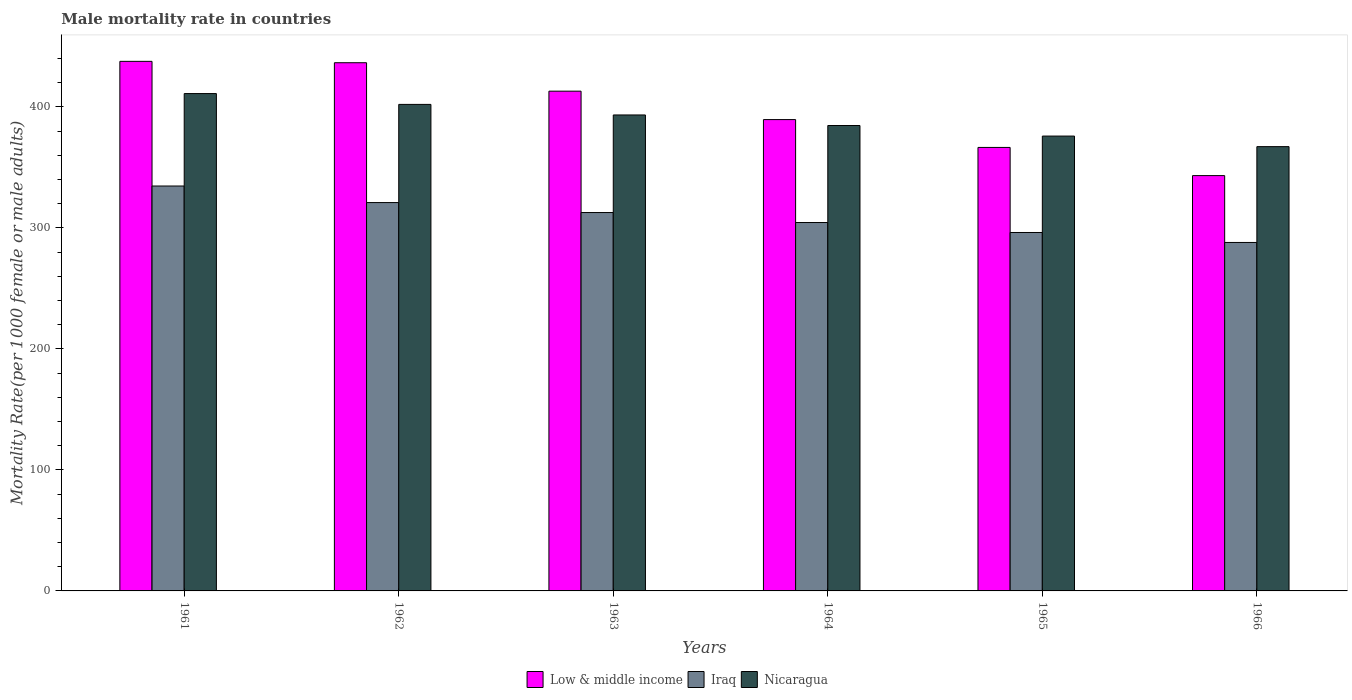Are the number of bars per tick equal to the number of legend labels?
Keep it short and to the point. Yes. Are the number of bars on each tick of the X-axis equal?
Keep it short and to the point. Yes. What is the label of the 6th group of bars from the left?
Give a very brief answer. 1966. What is the male mortality rate in Nicaragua in 1963?
Keep it short and to the point. 393.4. Across all years, what is the maximum male mortality rate in Low & middle income?
Your response must be concise. 437.7. Across all years, what is the minimum male mortality rate in Nicaragua?
Offer a terse response. 367.22. In which year was the male mortality rate in Low & middle income minimum?
Offer a terse response. 1966. What is the total male mortality rate in Iraq in the graph?
Your answer should be very brief. 1857.15. What is the difference between the male mortality rate in Iraq in 1963 and that in 1966?
Ensure brevity in your answer.  24.73. What is the difference between the male mortality rate in Nicaragua in 1966 and the male mortality rate in Low & middle income in 1963?
Give a very brief answer. -45.85. What is the average male mortality rate in Nicaragua per year?
Provide a short and direct response. 389.07. In the year 1961, what is the difference between the male mortality rate in Low & middle income and male mortality rate in Nicaragua?
Your response must be concise. 26.63. In how many years, is the male mortality rate in Iraq greater than 420?
Ensure brevity in your answer.  0. What is the ratio of the male mortality rate in Nicaragua in 1961 to that in 1963?
Keep it short and to the point. 1.04. Is the male mortality rate in Nicaragua in 1964 less than that in 1965?
Your answer should be very brief. No. Is the difference between the male mortality rate in Low & middle income in 1963 and 1966 greater than the difference between the male mortality rate in Nicaragua in 1963 and 1966?
Keep it short and to the point. Yes. What is the difference between the highest and the second highest male mortality rate in Nicaragua?
Provide a short and direct response. 8.94. What is the difference between the highest and the lowest male mortality rate in Nicaragua?
Your response must be concise. 43.86. In how many years, is the male mortality rate in Low & middle income greater than the average male mortality rate in Low & middle income taken over all years?
Ensure brevity in your answer.  3. What does the 3rd bar from the left in 1962 represents?
Provide a short and direct response. Nicaragua. Is it the case that in every year, the sum of the male mortality rate in Nicaragua and male mortality rate in Iraq is greater than the male mortality rate in Low & middle income?
Offer a terse response. Yes. How many bars are there?
Keep it short and to the point. 18. How many years are there in the graph?
Keep it short and to the point. 6. What is the difference between two consecutive major ticks on the Y-axis?
Keep it short and to the point. 100. Are the values on the major ticks of Y-axis written in scientific E-notation?
Your answer should be very brief. No. Does the graph contain grids?
Your answer should be compact. No. How many legend labels are there?
Provide a succinct answer. 3. How are the legend labels stacked?
Provide a short and direct response. Horizontal. What is the title of the graph?
Ensure brevity in your answer.  Male mortality rate in countries. What is the label or title of the Y-axis?
Your response must be concise. Mortality Rate(per 1000 female or male adults). What is the Mortality Rate(per 1000 female or male adults) in Low & middle income in 1961?
Offer a terse response. 437.7. What is the Mortality Rate(per 1000 female or male adults) in Iraq in 1961?
Provide a succinct answer. 334.67. What is the Mortality Rate(per 1000 female or male adults) of Nicaragua in 1961?
Your answer should be very brief. 411.07. What is the Mortality Rate(per 1000 female or male adults) of Low & middle income in 1962?
Provide a succinct answer. 436.57. What is the Mortality Rate(per 1000 female or male adults) of Iraq in 1962?
Provide a short and direct response. 320.98. What is the Mortality Rate(per 1000 female or male adults) in Nicaragua in 1962?
Offer a very short reply. 402.13. What is the Mortality Rate(per 1000 female or male adults) of Low & middle income in 1963?
Provide a short and direct response. 413.06. What is the Mortality Rate(per 1000 female or male adults) in Iraq in 1963?
Keep it short and to the point. 312.74. What is the Mortality Rate(per 1000 female or male adults) of Nicaragua in 1963?
Your answer should be very brief. 393.4. What is the Mortality Rate(per 1000 female or male adults) of Low & middle income in 1964?
Give a very brief answer. 389.57. What is the Mortality Rate(per 1000 female or male adults) in Iraq in 1964?
Give a very brief answer. 304.5. What is the Mortality Rate(per 1000 female or male adults) of Nicaragua in 1964?
Make the answer very short. 384.67. What is the Mortality Rate(per 1000 female or male adults) of Low & middle income in 1965?
Your response must be concise. 366.55. What is the Mortality Rate(per 1000 female or male adults) of Iraq in 1965?
Keep it short and to the point. 296.25. What is the Mortality Rate(per 1000 female or male adults) in Nicaragua in 1965?
Offer a terse response. 375.94. What is the Mortality Rate(per 1000 female or male adults) in Low & middle income in 1966?
Your response must be concise. 343.27. What is the Mortality Rate(per 1000 female or male adults) of Iraq in 1966?
Your answer should be very brief. 288.01. What is the Mortality Rate(per 1000 female or male adults) in Nicaragua in 1966?
Offer a terse response. 367.22. Across all years, what is the maximum Mortality Rate(per 1000 female or male adults) of Low & middle income?
Make the answer very short. 437.7. Across all years, what is the maximum Mortality Rate(per 1000 female or male adults) of Iraq?
Make the answer very short. 334.67. Across all years, what is the maximum Mortality Rate(per 1000 female or male adults) in Nicaragua?
Ensure brevity in your answer.  411.07. Across all years, what is the minimum Mortality Rate(per 1000 female or male adults) in Low & middle income?
Your response must be concise. 343.27. Across all years, what is the minimum Mortality Rate(per 1000 female or male adults) in Iraq?
Provide a succinct answer. 288.01. Across all years, what is the minimum Mortality Rate(per 1000 female or male adults) of Nicaragua?
Offer a very short reply. 367.22. What is the total Mortality Rate(per 1000 female or male adults) in Low & middle income in the graph?
Provide a short and direct response. 2386.73. What is the total Mortality Rate(per 1000 female or male adults) in Iraq in the graph?
Your answer should be very brief. 1857.15. What is the total Mortality Rate(per 1000 female or male adults) in Nicaragua in the graph?
Provide a short and direct response. 2334.43. What is the difference between the Mortality Rate(per 1000 female or male adults) in Low & middle income in 1961 and that in 1962?
Your answer should be compact. 1.13. What is the difference between the Mortality Rate(per 1000 female or male adults) in Iraq in 1961 and that in 1962?
Give a very brief answer. 13.69. What is the difference between the Mortality Rate(per 1000 female or male adults) of Nicaragua in 1961 and that in 1962?
Your answer should be very brief. 8.94. What is the difference between the Mortality Rate(per 1000 female or male adults) in Low & middle income in 1961 and that in 1963?
Your answer should be very brief. 24.64. What is the difference between the Mortality Rate(per 1000 female or male adults) of Iraq in 1961 and that in 1963?
Your answer should be very brief. 21.93. What is the difference between the Mortality Rate(per 1000 female or male adults) in Nicaragua in 1961 and that in 1963?
Your response must be concise. 17.67. What is the difference between the Mortality Rate(per 1000 female or male adults) in Low & middle income in 1961 and that in 1964?
Ensure brevity in your answer.  48.13. What is the difference between the Mortality Rate(per 1000 female or male adults) of Iraq in 1961 and that in 1964?
Your answer should be compact. 30.17. What is the difference between the Mortality Rate(per 1000 female or male adults) in Nicaragua in 1961 and that in 1964?
Offer a terse response. 26.4. What is the difference between the Mortality Rate(per 1000 female or male adults) of Low & middle income in 1961 and that in 1965?
Your answer should be very brief. 71.15. What is the difference between the Mortality Rate(per 1000 female or male adults) of Iraq in 1961 and that in 1965?
Keep it short and to the point. 38.42. What is the difference between the Mortality Rate(per 1000 female or male adults) of Nicaragua in 1961 and that in 1965?
Keep it short and to the point. 35.13. What is the difference between the Mortality Rate(per 1000 female or male adults) in Low & middle income in 1961 and that in 1966?
Keep it short and to the point. 94.43. What is the difference between the Mortality Rate(per 1000 female or male adults) of Iraq in 1961 and that in 1966?
Give a very brief answer. 46.66. What is the difference between the Mortality Rate(per 1000 female or male adults) of Nicaragua in 1961 and that in 1966?
Offer a terse response. 43.86. What is the difference between the Mortality Rate(per 1000 female or male adults) in Low & middle income in 1962 and that in 1963?
Keep it short and to the point. 23.51. What is the difference between the Mortality Rate(per 1000 female or male adults) in Iraq in 1962 and that in 1963?
Give a very brief answer. 8.24. What is the difference between the Mortality Rate(per 1000 female or male adults) of Nicaragua in 1962 and that in 1963?
Your answer should be very brief. 8.73. What is the difference between the Mortality Rate(per 1000 female or male adults) of Low & middle income in 1962 and that in 1964?
Provide a short and direct response. 47. What is the difference between the Mortality Rate(per 1000 female or male adults) in Iraq in 1962 and that in 1964?
Your answer should be very brief. 16.48. What is the difference between the Mortality Rate(per 1000 female or male adults) of Nicaragua in 1962 and that in 1964?
Give a very brief answer. 17.46. What is the difference between the Mortality Rate(per 1000 female or male adults) in Low & middle income in 1962 and that in 1965?
Offer a very short reply. 70.02. What is the difference between the Mortality Rate(per 1000 female or male adults) in Iraq in 1962 and that in 1965?
Provide a short and direct response. 24.73. What is the difference between the Mortality Rate(per 1000 female or male adults) of Nicaragua in 1962 and that in 1965?
Offer a very short reply. 26.18. What is the difference between the Mortality Rate(per 1000 female or male adults) of Low & middle income in 1962 and that in 1966?
Your response must be concise. 93.29. What is the difference between the Mortality Rate(per 1000 female or male adults) of Iraq in 1962 and that in 1966?
Ensure brevity in your answer.  32.97. What is the difference between the Mortality Rate(per 1000 female or male adults) of Nicaragua in 1962 and that in 1966?
Offer a terse response. 34.91. What is the difference between the Mortality Rate(per 1000 female or male adults) of Low & middle income in 1963 and that in 1964?
Provide a short and direct response. 23.5. What is the difference between the Mortality Rate(per 1000 female or male adults) of Iraq in 1963 and that in 1964?
Give a very brief answer. 8.24. What is the difference between the Mortality Rate(per 1000 female or male adults) in Nicaragua in 1963 and that in 1964?
Offer a very short reply. 8.73. What is the difference between the Mortality Rate(per 1000 female or male adults) in Low & middle income in 1963 and that in 1965?
Your answer should be compact. 46.51. What is the difference between the Mortality Rate(per 1000 female or male adults) in Iraq in 1963 and that in 1965?
Give a very brief answer. 16.48. What is the difference between the Mortality Rate(per 1000 female or male adults) in Nicaragua in 1963 and that in 1965?
Your answer should be very brief. 17.46. What is the difference between the Mortality Rate(per 1000 female or male adults) in Low & middle income in 1963 and that in 1966?
Keep it short and to the point. 69.79. What is the difference between the Mortality Rate(per 1000 female or male adults) of Iraq in 1963 and that in 1966?
Make the answer very short. 24.73. What is the difference between the Mortality Rate(per 1000 female or male adults) of Nicaragua in 1963 and that in 1966?
Your answer should be compact. 26.18. What is the difference between the Mortality Rate(per 1000 female or male adults) in Low & middle income in 1964 and that in 1965?
Make the answer very short. 23.02. What is the difference between the Mortality Rate(per 1000 female or male adults) of Iraq in 1964 and that in 1965?
Your answer should be very brief. 8.24. What is the difference between the Mortality Rate(per 1000 female or male adults) of Nicaragua in 1964 and that in 1965?
Provide a short and direct response. 8.73. What is the difference between the Mortality Rate(per 1000 female or male adults) of Low & middle income in 1964 and that in 1966?
Your answer should be very brief. 46.29. What is the difference between the Mortality Rate(per 1000 female or male adults) of Iraq in 1964 and that in 1966?
Offer a terse response. 16.48. What is the difference between the Mortality Rate(per 1000 female or male adults) of Nicaragua in 1964 and that in 1966?
Offer a terse response. 17.46. What is the difference between the Mortality Rate(per 1000 female or male adults) in Low & middle income in 1965 and that in 1966?
Your answer should be very brief. 23.28. What is the difference between the Mortality Rate(per 1000 female or male adults) of Iraq in 1965 and that in 1966?
Ensure brevity in your answer.  8.24. What is the difference between the Mortality Rate(per 1000 female or male adults) of Nicaragua in 1965 and that in 1966?
Offer a very short reply. 8.73. What is the difference between the Mortality Rate(per 1000 female or male adults) in Low & middle income in 1961 and the Mortality Rate(per 1000 female or male adults) in Iraq in 1962?
Make the answer very short. 116.72. What is the difference between the Mortality Rate(per 1000 female or male adults) of Low & middle income in 1961 and the Mortality Rate(per 1000 female or male adults) of Nicaragua in 1962?
Your answer should be very brief. 35.57. What is the difference between the Mortality Rate(per 1000 female or male adults) in Iraq in 1961 and the Mortality Rate(per 1000 female or male adults) in Nicaragua in 1962?
Provide a succinct answer. -67.46. What is the difference between the Mortality Rate(per 1000 female or male adults) in Low & middle income in 1961 and the Mortality Rate(per 1000 female or male adults) in Iraq in 1963?
Make the answer very short. 124.97. What is the difference between the Mortality Rate(per 1000 female or male adults) in Low & middle income in 1961 and the Mortality Rate(per 1000 female or male adults) in Nicaragua in 1963?
Give a very brief answer. 44.3. What is the difference between the Mortality Rate(per 1000 female or male adults) in Iraq in 1961 and the Mortality Rate(per 1000 female or male adults) in Nicaragua in 1963?
Offer a very short reply. -58.73. What is the difference between the Mortality Rate(per 1000 female or male adults) of Low & middle income in 1961 and the Mortality Rate(per 1000 female or male adults) of Iraq in 1964?
Ensure brevity in your answer.  133.21. What is the difference between the Mortality Rate(per 1000 female or male adults) of Low & middle income in 1961 and the Mortality Rate(per 1000 female or male adults) of Nicaragua in 1964?
Keep it short and to the point. 53.03. What is the difference between the Mortality Rate(per 1000 female or male adults) of Iraq in 1961 and the Mortality Rate(per 1000 female or male adults) of Nicaragua in 1964?
Keep it short and to the point. -50. What is the difference between the Mortality Rate(per 1000 female or male adults) in Low & middle income in 1961 and the Mortality Rate(per 1000 female or male adults) in Iraq in 1965?
Your answer should be very brief. 141.45. What is the difference between the Mortality Rate(per 1000 female or male adults) of Low & middle income in 1961 and the Mortality Rate(per 1000 female or male adults) of Nicaragua in 1965?
Offer a very short reply. 61.76. What is the difference between the Mortality Rate(per 1000 female or male adults) of Iraq in 1961 and the Mortality Rate(per 1000 female or male adults) of Nicaragua in 1965?
Provide a short and direct response. -41.27. What is the difference between the Mortality Rate(per 1000 female or male adults) in Low & middle income in 1961 and the Mortality Rate(per 1000 female or male adults) in Iraq in 1966?
Your answer should be compact. 149.69. What is the difference between the Mortality Rate(per 1000 female or male adults) in Low & middle income in 1961 and the Mortality Rate(per 1000 female or male adults) in Nicaragua in 1966?
Ensure brevity in your answer.  70.49. What is the difference between the Mortality Rate(per 1000 female or male adults) in Iraq in 1961 and the Mortality Rate(per 1000 female or male adults) in Nicaragua in 1966?
Keep it short and to the point. -32.55. What is the difference between the Mortality Rate(per 1000 female or male adults) in Low & middle income in 1962 and the Mortality Rate(per 1000 female or male adults) in Iraq in 1963?
Make the answer very short. 123.83. What is the difference between the Mortality Rate(per 1000 female or male adults) of Low & middle income in 1962 and the Mortality Rate(per 1000 female or male adults) of Nicaragua in 1963?
Your answer should be very brief. 43.17. What is the difference between the Mortality Rate(per 1000 female or male adults) in Iraq in 1962 and the Mortality Rate(per 1000 female or male adults) in Nicaragua in 1963?
Ensure brevity in your answer.  -72.42. What is the difference between the Mortality Rate(per 1000 female or male adults) in Low & middle income in 1962 and the Mortality Rate(per 1000 female or male adults) in Iraq in 1964?
Provide a succinct answer. 132.07. What is the difference between the Mortality Rate(per 1000 female or male adults) in Low & middle income in 1962 and the Mortality Rate(per 1000 female or male adults) in Nicaragua in 1964?
Your response must be concise. 51.9. What is the difference between the Mortality Rate(per 1000 female or male adults) of Iraq in 1962 and the Mortality Rate(per 1000 female or male adults) of Nicaragua in 1964?
Provide a short and direct response. -63.69. What is the difference between the Mortality Rate(per 1000 female or male adults) of Low & middle income in 1962 and the Mortality Rate(per 1000 female or male adults) of Iraq in 1965?
Offer a very short reply. 140.32. What is the difference between the Mortality Rate(per 1000 female or male adults) in Low & middle income in 1962 and the Mortality Rate(per 1000 female or male adults) in Nicaragua in 1965?
Provide a short and direct response. 60.63. What is the difference between the Mortality Rate(per 1000 female or male adults) of Iraq in 1962 and the Mortality Rate(per 1000 female or male adults) of Nicaragua in 1965?
Your answer should be compact. -54.96. What is the difference between the Mortality Rate(per 1000 female or male adults) of Low & middle income in 1962 and the Mortality Rate(per 1000 female or male adults) of Iraq in 1966?
Ensure brevity in your answer.  148.56. What is the difference between the Mortality Rate(per 1000 female or male adults) in Low & middle income in 1962 and the Mortality Rate(per 1000 female or male adults) in Nicaragua in 1966?
Your answer should be very brief. 69.35. What is the difference between the Mortality Rate(per 1000 female or male adults) of Iraq in 1962 and the Mortality Rate(per 1000 female or male adults) of Nicaragua in 1966?
Your answer should be very brief. -46.24. What is the difference between the Mortality Rate(per 1000 female or male adults) of Low & middle income in 1963 and the Mortality Rate(per 1000 female or male adults) of Iraq in 1964?
Offer a very short reply. 108.57. What is the difference between the Mortality Rate(per 1000 female or male adults) in Low & middle income in 1963 and the Mortality Rate(per 1000 female or male adults) in Nicaragua in 1964?
Provide a short and direct response. 28.39. What is the difference between the Mortality Rate(per 1000 female or male adults) of Iraq in 1963 and the Mortality Rate(per 1000 female or male adults) of Nicaragua in 1964?
Give a very brief answer. -71.93. What is the difference between the Mortality Rate(per 1000 female or male adults) of Low & middle income in 1963 and the Mortality Rate(per 1000 female or male adults) of Iraq in 1965?
Your response must be concise. 116.81. What is the difference between the Mortality Rate(per 1000 female or male adults) in Low & middle income in 1963 and the Mortality Rate(per 1000 female or male adults) in Nicaragua in 1965?
Offer a terse response. 37.12. What is the difference between the Mortality Rate(per 1000 female or male adults) of Iraq in 1963 and the Mortality Rate(per 1000 female or male adults) of Nicaragua in 1965?
Offer a terse response. -63.21. What is the difference between the Mortality Rate(per 1000 female or male adults) of Low & middle income in 1963 and the Mortality Rate(per 1000 female or male adults) of Iraq in 1966?
Offer a very short reply. 125.05. What is the difference between the Mortality Rate(per 1000 female or male adults) of Low & middle income in 1963 and the Mortality Rate(per 1000 female or male adults) of Nicaragua in 1966?
Provide a short and direct response. 45.85. What is the difference between the Mortality Rate(per 1000 female or male adults) of Iraq in 1963 and the Mortality Rate(per 1000 female or male adults) of Nicaragua in 1966?
Provide a short and direct response. -54.48. What is the difference between the Mortality Rate(per 1000 female or male adults) in Low & middle income in 1964 and the Mortality Rate(per 1000 female or male adults) in Iraq in 1965?
Offer a very short reply. 93.31. What is the difference between the Mortality Rate(per 1000 female or male adults) in Low & middle income in 1964 and the Mortality Rate(per 1000 female or male adults) in Nicaragua in 1965?
Your response must be concise. 13.62. What is the difference between the Mortality Rate(per 1000 female or male adults) in Iraq in 1964 and the Mortality Rate(per 1000 female or male adults) in Nicaragua in 1965?
Your answer should be very brief. -71.45. What is the difference between the Mortality Rate(per 1000 female or male adults) of Low & middle income in 1964 and the Mortality Rate(per 1000 female or male adults) of Iraq in 1966?
Your response must be concise. 101.56. What is the difference between the Mortality Rate(per 1000 female or male adults) in Low & middle income in 1964 and the Mortality Rate(per 1000 female or male adults) in Nicaragua in 1966?
Give a very brief answer. 22.35. What is the difference between the Mortality Rate(per 1000 female or male adults) of Iraq in 1964 and the Mortality Rate(per 1000 female or male adults) of Nicaragua in 1966?
Keep it short and to the point. -62.72. What is the difference between the Mortality Rate(per 1000 female or male adults) of Low & middle income in 1965 and the Mortality Rate(per 1000 female or male adults) of Iraq in 1966?
Your answer should be very brief. 78.54. What is the difference between the Mortality Rate(per 1000 female or male adults) of Low & middle income in 1965 and the Mortality Rate(per 1000 female or male adults) of Nicaragua in 1966?
Your answer should be compact. -0.66. What is the difference between the Mortality Rate(per 1000 female or male adults) in Iraq in 1965 and the Mortality Rate(per 1000 female or male adults) in Nicaragua in 1966?
Offer a terse response. -70.96. What is the average Mortality Rate(per 1000 female or male adults) of Low & middle income per year?
Make the answer very short. 397.79. What is the average Mortality Rate(per 1000 female or male adults) of Iraq per year?
Provide a short and direct response. 309.52. What is the average Mortality Rate(per 1000 female or male adults) of Nicaragua per year?
Ensure brevity in your answer.  389.07. In the year 1961, what is the difference between the Mortality Rate(per 1000 female or male adults) of Low & middle income and Mortality Rate(per 1000 female or male adults) of Iraq?
Provide a succinct answer. 103.03. In the year 1961, what is the difference between the Mortality Rate(per 1000 female or male adults) of Low & middle income and Mortality Rate(per 1000 female or male adults) of Nicaragua?
Ensure brevity in your answer.  26.63. In the year 1961, what is the difference between the Mortality Rate(per 1000 female or male adults) of Iraq and Mortality Rate(per 1000 female or male adults) of Nicaragua?
Make the answer very short. -76.4. In the year 1962, what is the difference between the Mortality Rate(per 1000 female or male adults) of Low & middle income and Mortality Rate(per 1000 female or male adults) of Iraq?
Provide a succinct answer. 115.59. In the year 1962, what is the difference between the Mortality Rate(per 1000 female or male adults) in Low & middle income and Mortality Rate(per 1000 female or male adults) in Nicaragua?
Give a very brief answer. 34.44. In the year 1962, what is the difference between the Mortality Rate(per 1000 female or male adults) in Iraq and Mortality Rate(per 1000 female or male adults) in Nicaragua?
Provide a short and direct response. -81.15. In the year 1963, what is the difference between the Mortality Rate(per 1000 female or male adults) of Low & middle income and Mortality Rate(per 1000 female or male adults) of Iraq?
Make the answer very short. 100.33. In the year 1963, what is the difference between the Mortality Rate(per 1000 female or male adults) of Low & middle income and Mortality Rate(per 1000 female or male adults) of Nicaragua?
Your response must be concise. 19.66. In the year 1963, what is the difference between the Mortality Rate(per 1000 female or male adults) of Iraq and Mortality Rate(per 1000 female or male adults) of Nicaragua?
Offer a terse response. -80.66. In the year 1964, what is the difference between the Mortality Rate(per 1000 female or male adults) of Low & middle income and Mortality Rate(per 1000 female or male adults) of Iraq?
Offer a very short reply. 85.07. In the year 1964, what is the difference between the Mortality Rate(per 1000 female or male adults) in Low & middle income and Mortality Rate(per 1000 female or male adults) in Nicaragua?
Your answer should be compact. 4.9. In the year 1964, what is the difference between the Mortality Rate(per 1000 female or male adults) of Iraq and Mortality Rate(per 1000 female or male adults) of Nicaragua?
Provide a succinct answer. -80.18. In the year 1965, what is the difference between the Mortality Rate(per 1000 female or male adults) in Low & middle income and Mortality Rate(per 1000 female or male adults) in Iraq?
Offer a very short reply. 70.3. In the year 1965, what is the difference between the Mortality Rate(per 1000 female or male adults) in Low & middle income and Mortality Rate(per 1000 female or male adults) in Nicaragua?
Your answer should be compact. -9.39. In the year 1965, what is the difference between the Mortality Rate(per 1000 female or male adults) of Iraq and Mortality Rate(per 1000 female or male adults) of Nicaragua?
Ensure brevity in your answer.  -79.69. In the year 1966, what is the difference between the Mortality Rate(per 1000 female or male adults) in Low & middle income and Mortality Rate(per 1000 female or male adults) in Iraq?
Offer a very short reply. 55.26. In the year 1966, what is the difference between the Mortality Rate(per 1000 female or male adults) in Low & middle income and Mortality Rate(per 1000 female or male adults) in Nicaragua?
Your response must be concise. -23.94. In the year 1966, what is the difference between the Mortality Rate(per 1000 female or male adults) in Iraq and Mortality Rate(per 1000 female or male adults) in Nicaragua?
Your response must be concise. -79.2. What is the ratio of the Mortality Rate(per 1000 female or male adults) in Iraq in 1961 to that in 1962?
Give a very brief answer. 1.04. What is the ratio of the Mortality Rate(per 1000 female or male adults) of Nicaragua in 1961 to that in 1962?
Keep it short and to the point. 1.02. What is the ratio of the Mortality Rate(per 1000 female or male adults) in Low & middle income in 1961 to that in 1963?
Your answer should be compact. 1.06. What is the ratio of the Mortality Rate(per 1000 female or male adults) of Iraq in 1961 to that in 1963?
Your answer should be compact. 1.07. What is the ratio of the Mortality Rate(per 1000 female or male adults) of Nicaragua in 1961 to that in 1963?
Your answer should be compact. 1.04. What is the ratio of the Mortality Rate(per 1000 female or male adults) of Low & middle income in 1961 to that in 1964?
Make the answer very short. 1.12. What is the ratio of the Mortality Rate(per 1000 female or male adults) in Iraq in 1961 to that in 1964?
Give a very brief answer. 1.1. What is the ratio of the Mortality Rate(per 1000 female or male adults) of Nicaragua in 1961 to that in 1964?
Offer a terse response. 1.07. What is the ratio of the Mortality Rate(per 1000 female or male adults) in Low & middle income in 1961 to that in 1965?
Give a very brief answer. 1.19. What is the ratio of the Mortality Rate(per 1000 female or male adults) in Iraq in 1961 to that in 1965?
Your answer should be very brief. 1.13. What is the ratio of the Mortality Rate(per 1000 female or male adults) of Nicaragua in 1961 to that in 1965?
Your answer should be compact. 1.09. What is the ratio of the Mortality Rate(per 1000 female or male adults) of Low & middle income in 1961 to that in 1966?
Offer a terse response. 1.28. What is the ratio of the Mortality Rate(per 1000 female or male adults) of Iraq in 1961 to that in 1966?
Offer a very short reply. 1.16. What is the ratio of the Mortality Rate(per 1000 female or male adults) of Nicaragua in 1961 to that in 1966?
Provide a succinct answer. 1.12. What is the ratio of the Mortality Rate(per 1000 female or male adults) in Low & middle income in 1962 to that in 1963?
Your answer should be compact. 1.06. What is the ratio of the Mortality Rate(per 1000 female or male adults) of Iraq in 1962 to that in 1963?
Ensure brevity in your answer.  1.03. What is the ratio of the Mortality Rate(per 1000 female or male adults) of Nicaragua in 1962 to that in 1963?
Offer a very short reply. 1.02. What is the ratio of the Mortality Rate(per 1000 female or male adults) in Low & middle income in 1962 to that in 1964?
Offer a terse response. 1.12. What is the ratio of the Mortality Rate(per 1000 female or male adults) in Iraq in 1962 to that in 1964?
Your answer should be compact. 1.05. What is the ratio of the Mortality Rate(per 1000 female or male adults) of Nicaragua in 1962 to that in 1964?
Ensure brevity in your answer.  1.05. What is the ratio of the Mortality Rate(per 1000 female or male adults) in Low & middle income in 1962 to that in 1965?
Offer a terse response. 1.19. What is the ratio of the Mortality Rate(per 1000 female or male adults) in Iraq in 1962 to that in 1965?
Offer a very short reply. 1.08. What is the ratio of the Mortality Rate(per 1000 female or male adults) in Nicaragua in 1962 to that in 1965?
Offer a very short reply. 1.07. What is the ratio of the Mortality Rate(per 1000 female or male adults) in Low & middle income in 1962 to that in 1966?
Your response must be concise. 1.27. What is the ratio of the Mortality Rate(per 1000 female or male adults) in Iraq in 1962 to that in 1966?
Keep it short and to the point. 1.11. What is the ratio of the Mortality Rate(per 1000 female or male adults) in Nicaragua in 1962 to that in 1966?
Provide a succinct answer. 1.1. What is the ratio of the Mortality Rate(per 1000 female or male adults) in Low & middle income in 1963 to that in 1964?
Your response must be concise. 1.06. What is the ratio of the Mortality Rate(per 1000 female or male adults) of Iraq in 1963 to that in 1964?
Your answer should be very brief. 1.03. What is the ratio of the Mortality Rate(per 1000 female or male adults) in Nicaragua in 1963 to that in 1964?
Make the answer very short. 1.02. What is the ratio of the Mortality Rate(per 1000 female or male adults) in Low & middle income in 1963 to that in 1965?
Ensure brevity in your answer.  1.13. What is the ratio of the Mortality Rate(per 1000 female or male adults) of Iraq in 1963 to that in 1965?
Offer a terse response. 1.06. What is the ratio of the Mortality Rate(per 1000 female or male adults) in Nicaragua in 1963 to that in 1965?
Offer a very short reply. 1.05. What is the ratio of the Mortality Rate(per 1000 female or male adults) of Low & middle income in 1963 to that in 1966?
Provide a succinct answer. 1.2. What is the ratio of the Mortality Rate(per 1000 female or male adults) of Iraq in 1963 to that in 1966?
Make the answer very short. 1.09. What is the ratio of the Mortality Rate(per 1000 female or male adults) of Nicaragua in 1963 to that in 1966?
Your answer should be compact. 1.07. What is the ratio of the Mortality Rate(per 1000 female or male adults) in Low & middle income in 1964 to that in 1965?
Give a very brief answer. 1.06. What is the ratio of the Mortality Rate(per 1000 female or male adults) of Iraq in 1964 to that in 1965?
Offer a terse response. 1.03. What is the ratio of the Mortality Rate(per 1000 female or male adults) of Nicaragua in 1964 to that in 1965?
Your answer should be compact. 1.02. What is the ratio of the Mortality Rate(per 1000 female or male adults) of Low & middle income in 1964 to that in 1966?
Provide a short and direct response. 1.13. What is the ratio of the Mortality Rate(per 1000 female or male adults) of Iraq in 1964 to that in 1966?
Provide a short and direct response. 1.06. What is the ratio of the Mortality Rate(per 1000 female or male adults) of Nicaragua in 1964 to that in 1966?
Provide a succinct answer. 1.05. What is the ratio of the Mortality Rate(per 1000 female or male adults) in Low & middle income in 1965 to that in 1966?
Your answer should be very brief. 1.07. What is the ratio of the Mortality Rate(per 1000 female or male adults) of Iraq in 1965 to that in 1966?
Provide a short and direct response. 1.03. What is the ratio of the Mortality Rate(per 1000 female or male adults) of Nicaragua in 1965 to that in 1966?
Your response must be concise. 1.02. What is the difference between the highest and the second highest Mortality Rate(per 1000 female or male adults) in Low & middle income?
Give a very brief answer. 1.13. What is the difference between the highest and the second highest Mortality Rate(per 1000 female or male adults) in Iraq?
Offer a terse response. 13.69. What is the difference between the highest and the second highest Mortality Rate(per 1000 female or male adults) of Nicaragua?
Your response must be concise. 8.94. What is the difference between the highest and the lowest Mortality Rate(per 1000 female or male adults) in Low & middle income?
Your answer should be very brief. 94.43. What is the difference between the highest and the lowest Mortality Rate(per 1000 female or male adults) of Iraq?
Offer a very short reply. 46.66. What is the difference between the highest and the lowest Mortality Rate(per 1000 female or male adults) of Nicaragua?
Keep it short and to the point. 43.86. 